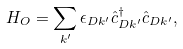Convert formula to latex. <formula><loc_0><loc_0><loc_500><loc_500>H _ { O } = \sum _ { k ^ { \prime } } \epsilon _ { D k ^ { \prime } } \hat { c } ^ { \dag } _ { D k ^ { \prime } } \hat { c } _ { D k ^ { \prime } } ,</formula> 